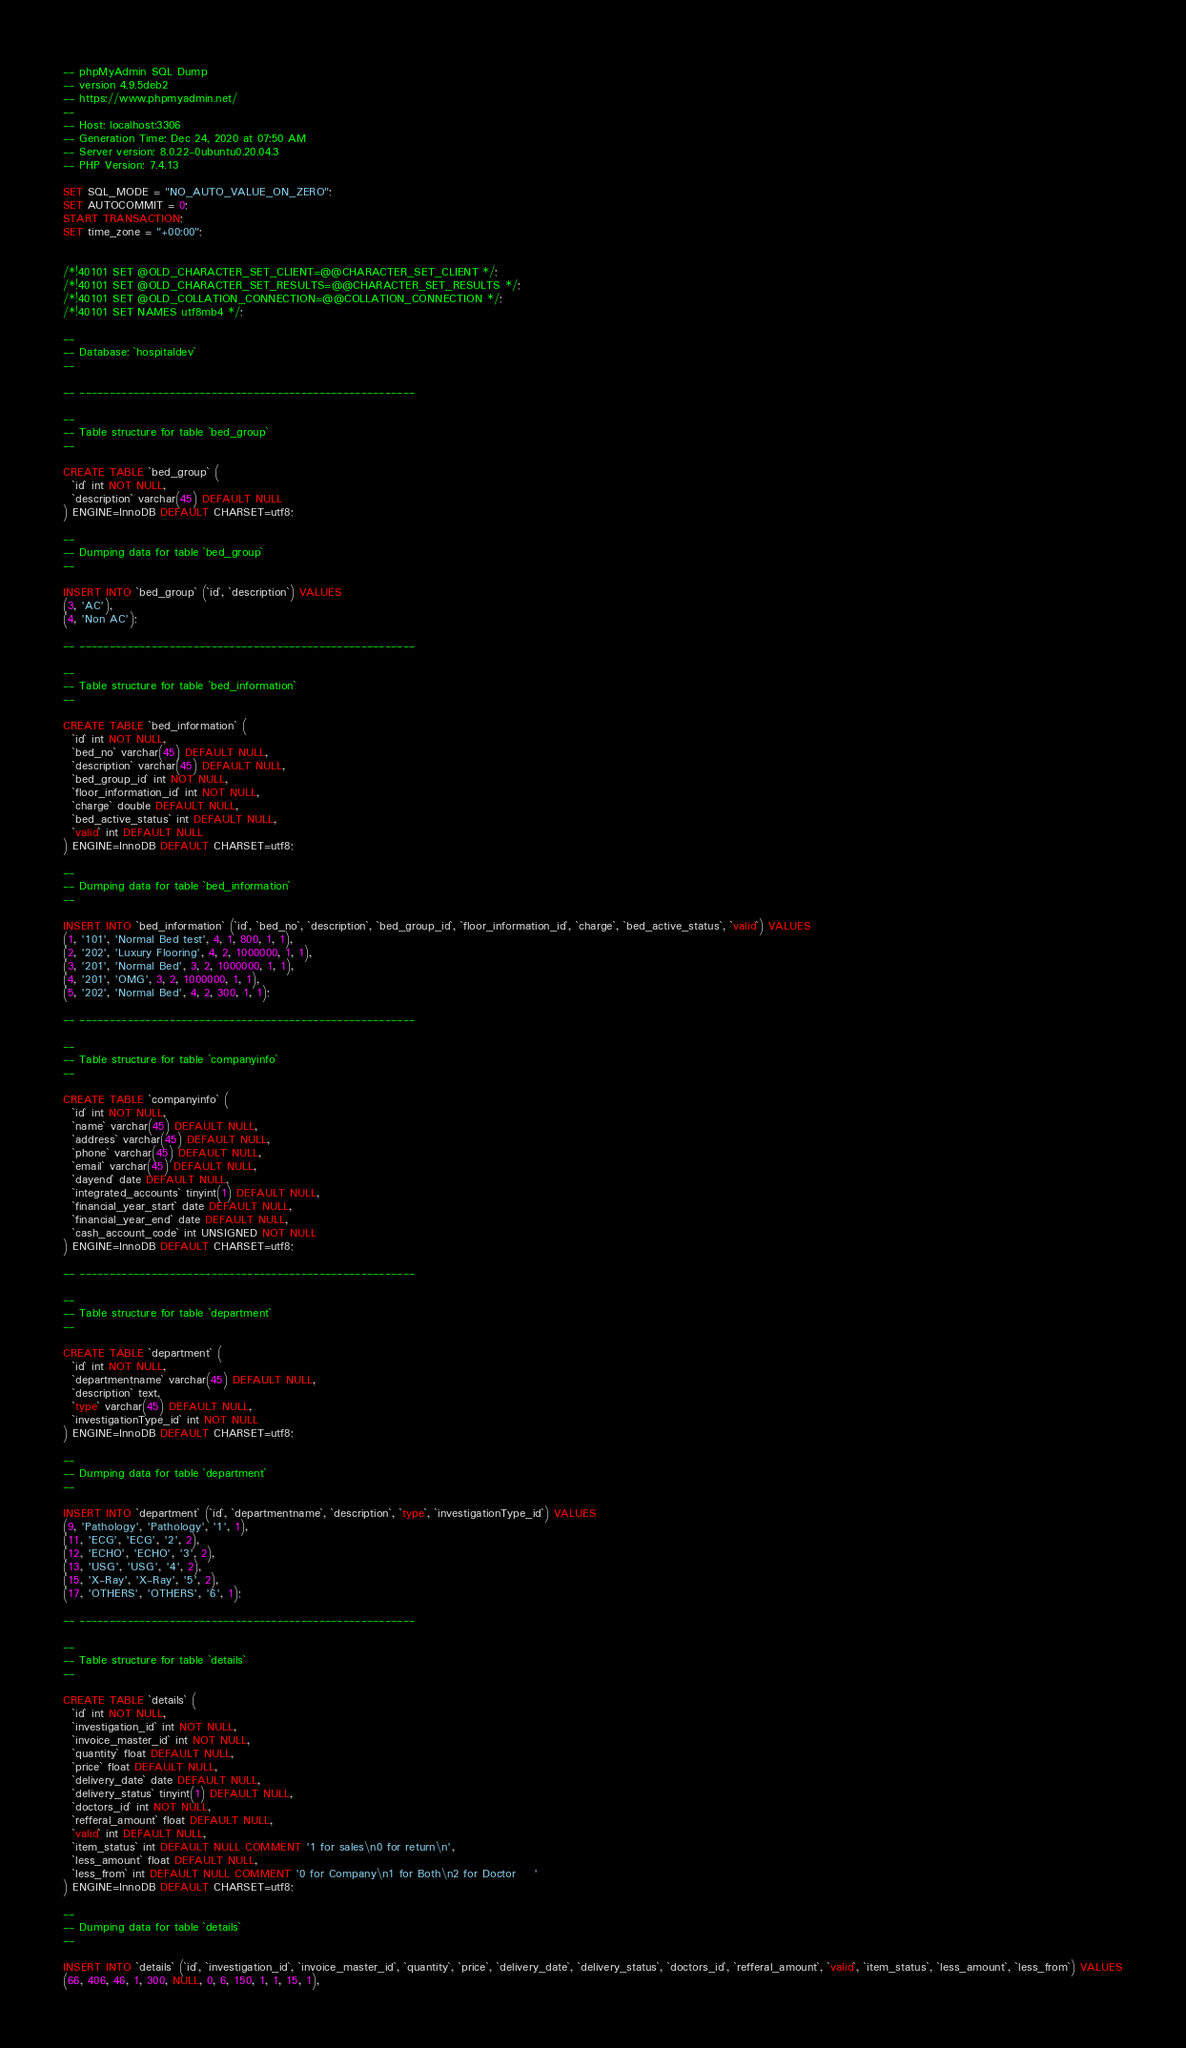<code> <loc_0><loc_0><loc_500><loc_500><_SQL_>-- phpMyAdmin SQL Dump
-- version 4.9.5deb2
-- https://www.phpmyadmin.net/
--
-- Host: localhost:3306
-- Generation Time: Dec 24, 2020 at 07:50 AM
-- Server version: 8.0.22-0ubuntu0.20.04.3
-- PHP Version: 7.4.13

SET SQL_MODE = "NO_AUTO_VALUE_ON_ZERO";
SET AUTOCOMMIT = 0;
START TRANSACTION;
SET time_zone = "+00:00";


/*!40101 SET @OLD_CHARACTER_SET_CLIENT=@@CHARACTER_SET_CLIENT */;
/*!40101 SET @OLD_CHARACTER_SET_RESULTS=@@CHARACTER_SET_RESULTS */;
/*!40101 SET @OLD_COLLATION_CONNECTION=@@COLLATION_CONNECTION */;
/*!40101 SET NAMES utf8mb4 */;

--
-- Database: `hospitaldev`
--

-- --------------------------------------------------------

--
-- Table structure for table `bed_group`
--

CREATE TABLE `bed_group` (
  `id` int NOT NULL,
  `description` varchar(45) DEFAULT NULL
) ENGINE=InnoDB DEFAULT CHARSET=utf8;

--
-- Dumping data for table `bed_group`
--

INSERT INTO `bed_group` (`id`, `description`) VALUES
(3, 'AC'),
(4, 'Non AC');

-- --------------------------------------------------------

--
-- Table structure for table `bed_information`
--

CREATE TABLE `bed_information` (
  `id` int NOT NULL,
  `bed_no` varchar(45) DEFAULT NULL,
  `description` varchar(45) DEFAULT NULL,
  `bed_group_id` int NOT NULL,
  `floor_information_id` int NOT NULL,
  `charge` double DEFAULT NULL,
  `bed_active_status` int DEFAULT NULL,
  `valid` int DEFAULT NULL
) ENGINE=InnoDB DEFAULT CHARSET=utf8;

--
-- Dumping data for table `bed_information`
--

INSERT INTO `bed_information` (`id`, `bed_no`, `description`, `bed_group_id`, `floor_information_id`, `charge`, `bed_active_status`, `valid`) VALUES
(1, '101', 'Normal Bed test', 4, 1, 800, 1, 1),
(2, '202', 'Luxury Flooring', 4, 2, 1000000, 1, 1),
(3, '201', 'Normal Bed', 3, 2, 1000000, 1, 1),
(4, '201', 'OMG', 3, 2, 1000000, 1, 1),
(5, '202', 'Normal Bed', 4, 2, 300, 1, 1);

-- --------------------------------------------------------

--
-- Table structure for table `companyinfo`
--

CREATE TABLE `companyinfo` (
  `id` int NOT NULL,
  `name` varchar(45) DEFAULT NULL,
  `address` varchar(45) DEFAULT NULL,
  `phone` varchar(45) DEFAULT NULL,
  `email` varchar(45) DEFAULT NULL,
  `dayend` date DEFAULT NULL,
  `integrated_accounts` tinyint(1) DEFAULT NULL,
  `financial_year_start` date DEFAULT NULL,
  `financial_year_end` date DEFAULT NULL,
  `cash_account_code` int UNSIGNED NOT NULL
) ENGINE=InnoDB DEFAULT CHARSET=utf8;

-- --------------------------------------------------------

--
-- Table structure for table `department`
--

CREATE TABLE `department` (
  `id` int NOT NULL,
  `departmentname` varchar(45) DEFAULT NULL,
  `description` text,
  `type` varchar(45) DEFAULT NULL,
  `investigationType_id` int NOT NULL
) ENGINE=InnoDB DEFAULT CHARSET=utf8;

--
-- Dumping data for table `department`
--

INSERT INTO `department` (`id`, `departmentname`, `description`, `type`, `investigationType_id`) VALUES
(9, 'Pathology', 'Pathology', '1', 1),
(11, 'ECG', 'ECG', '2', 2),
(12, 'ECHO', 'ECHO', '3', 2),
(13, 'USG', 'USG', '4', 2),
(15, 'X-Ray', 'X-Ray', '5', 2),
(17, 'OTHERS', 'OTHERS', '6', 1);

-- --------------------------------------------------------

--
-- Table structure for table `details`
--

CREATE TABLE `details` (
  `id` int NOT NULL,
  `investigation_id` int NOT NULL,
  `invoice_master_id` int NOT NULL,
  `quantity` float DEFAULT NULL,
  `price` float DEFAULT NULL,
  `delivery_date` date DEFAULT NULL,
  `delivery_status` tinyint(1) DEFAULT NULL,
  `doctors_id` int NOT NULL,
  `refferal_amount` float DEFAULT NULL,
  `valid` int DEFAULT NULL,
  `item_status` int DEFAULT NULL COMMENT '1 for sales\n0 for return\n',
  `less_amount` float DEFAULT NULL,
  `less_from` int DEFAULT NULL COMMENT '0 for Company\n1 for Both\n2 for Doctor	'
) ENGINE=InnoDB DEFAULT CHARSET=utf8;

--
-- Dumping data for table `details`
--

INSERT INTO `details` (`id`, `investigation_id`, `invoice_master_id`, `quantity`, `price`, `delivery_date`, `delivery_status`, `doctors_id`, `refferal_amount`, `valid`, `item_status`, `less_amount`, `less_from`) VALUES
(66, 406, 46, 1, 300, NULL, 0, 6, 150, 1, 1, 15, 1),</code> 